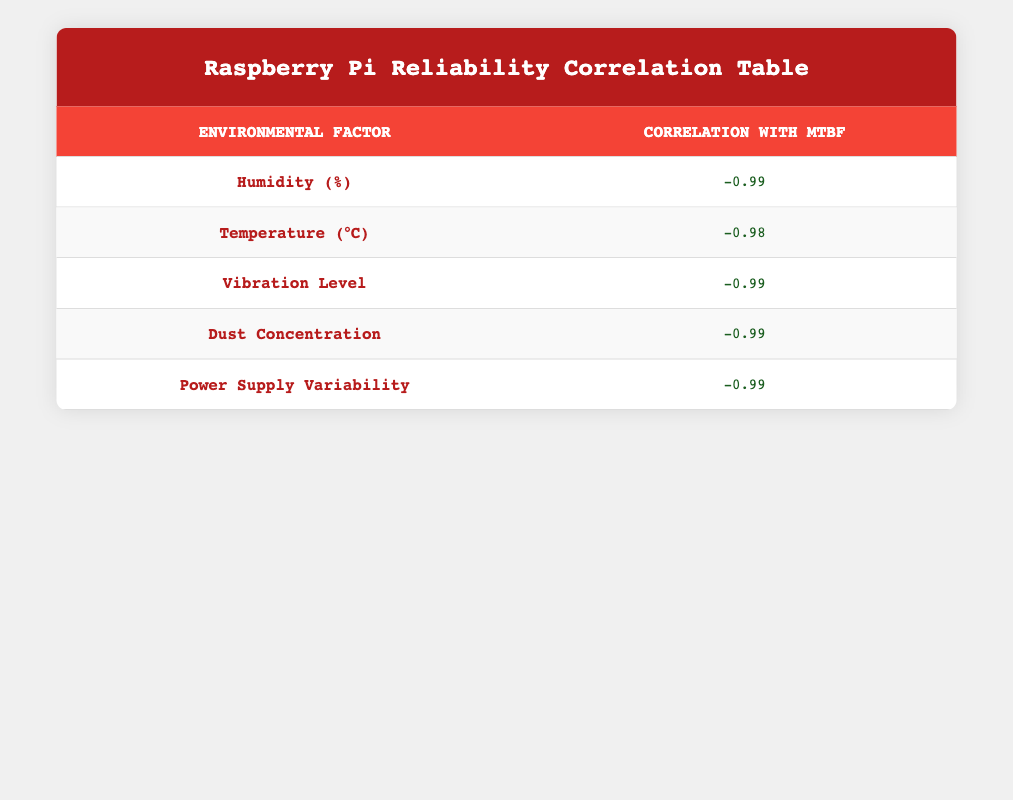What is the correlation value for humidity? The table shows that the correlation value for humidity with respect to mean time between failures is -0.98.
Answer: -0.98 Which environmental factor has the highest correlation with MTBF? The vibration level has the highest correlation with mean time between failures, with a value of -0.99.
Answer: Vibration Level If humidity increases by 10%, how will it affect the MTBF? Since the correlation for humidity is -0.98, an increase in humidity will likely decrease the MTBF significantly, indicating a strong inverse relationship.
Answer: Decrease MTBF Is the correlation value for temperature above or below -0.95? The table indicates it is -0.97, which is below -0.95. Thus, the correlation for temperature is indeed below that threshold.
Answer: Below What is the average correlation value among dust concentration and power supply variability? The values for dust concentration and power supply variability are both -0.98. The sum of these correlations is -0.98 + -0.98 = -1.96, and the average is -1.96 / 2 = -0.98.
Answer: -0.98 How does the vibration level correlate with MTBF compared to humidity? The correlation for vibration level is -0.99, while for humidity it is -0.98. This indicates that vibration level has a stronger negative correlation with MTBF than humidity.
Answer: Vibration level is stronger If the humidity were to be reduced to 20%, what would likely happen to the MTBF? Based on the correlation of humidity (-0.98), reducing humidity could significantly increase MTBF, as they have an inverse relationship.
Answer: Increase MTBF What would the change in MTBF be if dust concentration were to double? Dust concentration's correlation value is -0.98. Doubling the dust concentration is likely to decrease MTBF significantly due to the strong inverse correlation.
Answer: Decrease MTBF Does the power supply variability correlate positively with MTBF? No, the correlation value for power supply variability is -0.98, indicating a strong negative correlation.
Answer: No 